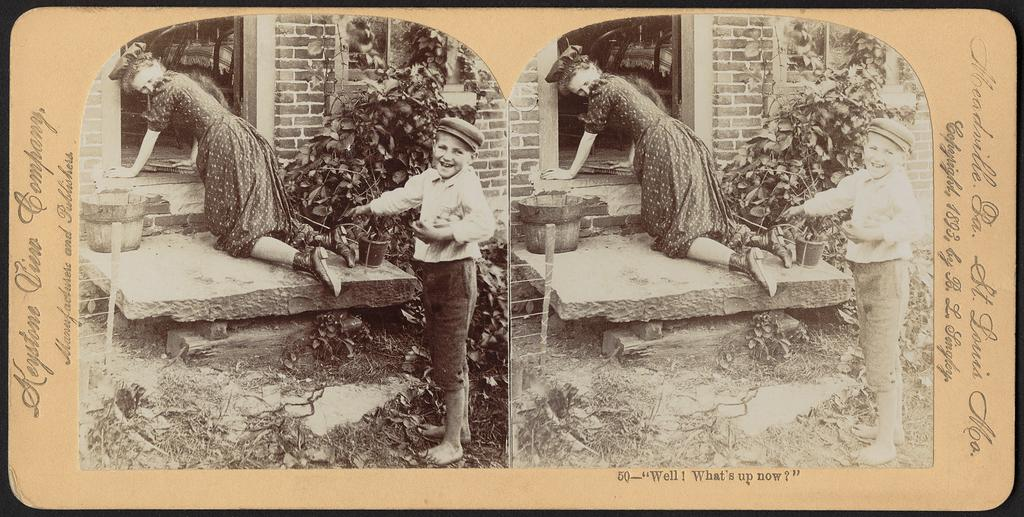What is the main subject of the image? The main subjects of the image are a boy and a girl. What is the boy doing in the image? The boy is standing in the image. What is the girl doing in the image? The girl is sitting on her knees in the image. Where is the girl located in relation to the door? The girl is near the door in the image. What type of plant can be seen in the image? There is a plant in a pot in the image. What is the background of the image made of? There is a wall in the image, which serves as the background. What other objects can be seen in the image? There is a basket and a ladder in the image. What type of flower is the boy holding in the image? There is no flower present in the image; the boy is not holding anything. 